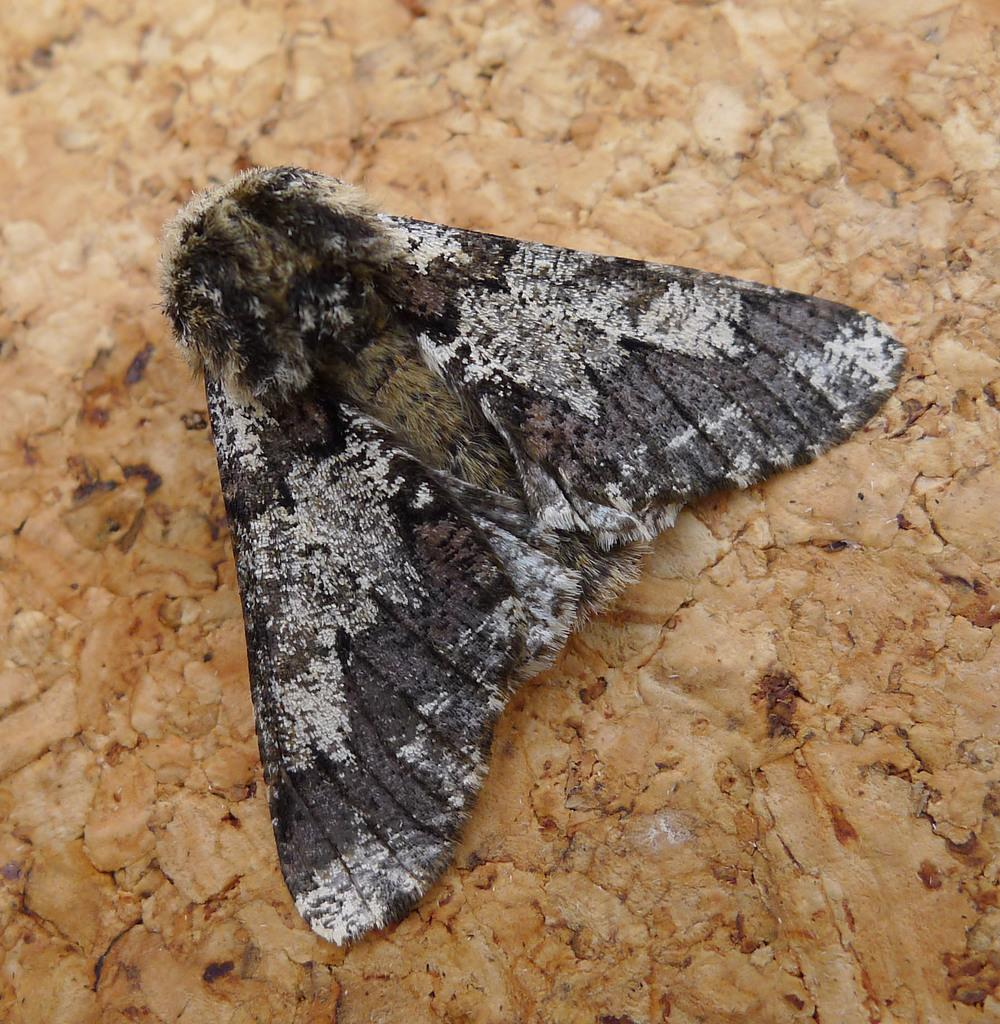What is present on the wooden surface in the image? There is a fly on the wooden surface in the image. Can you describe the wooden surface in the image? The wooden surface is the background on which the fly is present. How does the beggar interact with the fly in the image? There is no beggar present in the image, so there is no interaction between a beggar and the fly. 